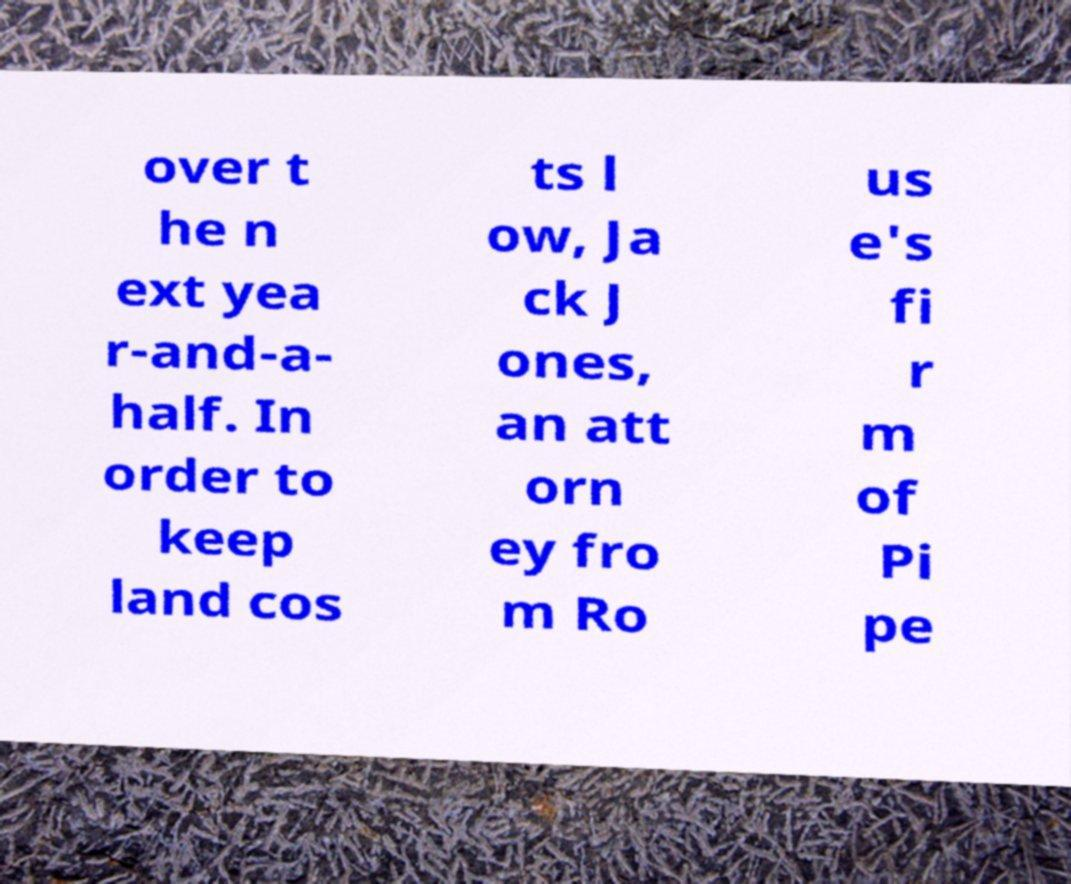Could you extract and type out the text from this image? over t he n ext yea r-and-a- half. In order to keep land cos ts l ow, Ja ck J ones, an att orn ey fro m Ro us e's fi r m of Pi pe 